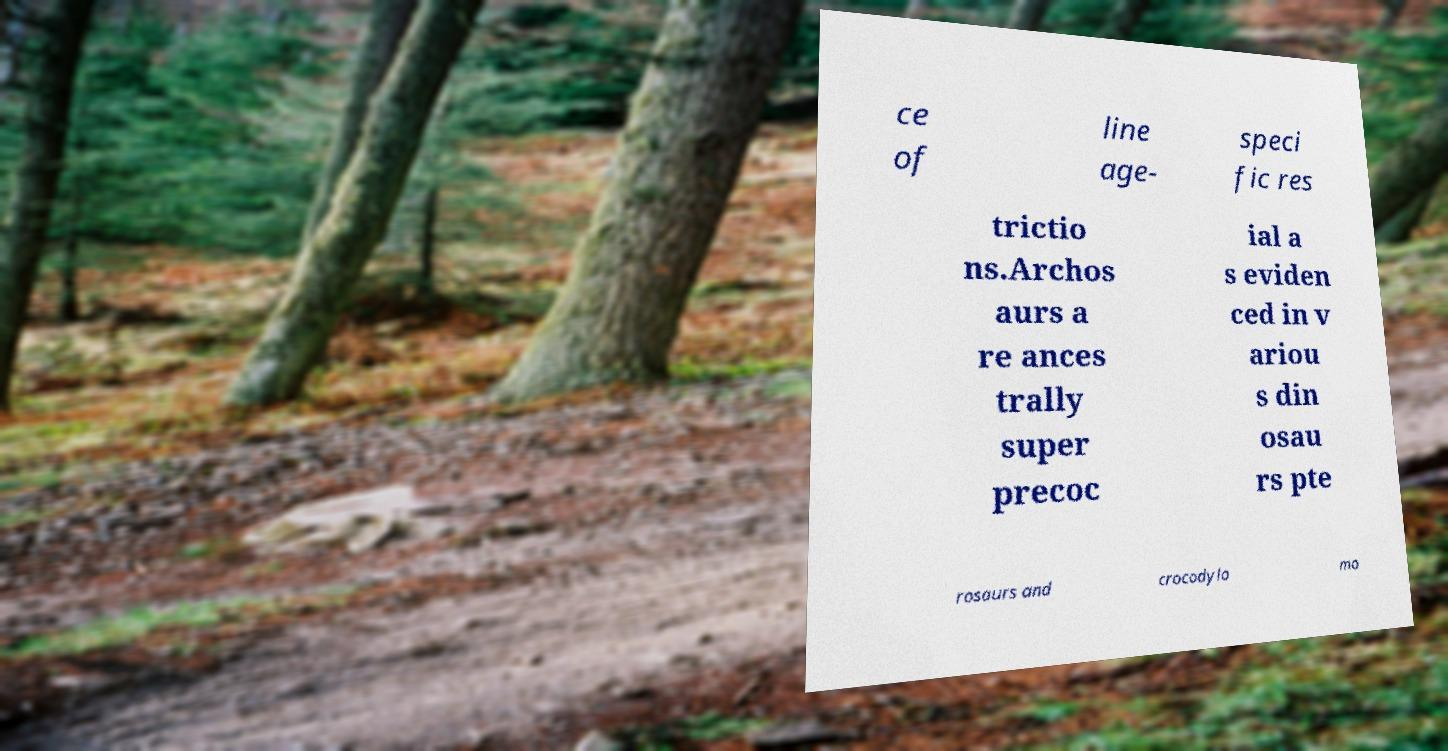Please identify and transcribe the text found in this image. ce of line age- speci fic res trictio ns.Archos aurs a re ances trally super precoc ial a s eviden ced in v ariou s din osau rs pte rosaurs and crocodylo mo 